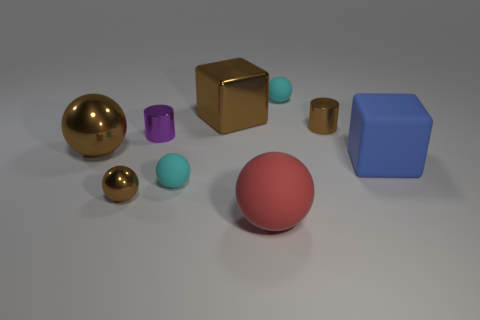Subtract all large rubber spheres. How many spheres are left? 4 Subtract all yellow blocks. How many brown balls are left? 2 Subtract all red balls. How many balls are left? 4 Add 1 red rubber things. How many objects exist? 10 Subtract all cylinders. How many objects are left? 7 Subtract all yellow spheres. Subtract all red cylinders. How many spheres are left? 5 Subtract all large red metallic balls. Subtract all rubber cubes. How many objects are left? 8 Add 6 red rubber balls. How many red rubber balls are left? 7 Add 6 large rubber balls. How many large rubber balls exist? 7 Subtract 1 cyan balls. How many objects are left? 8 